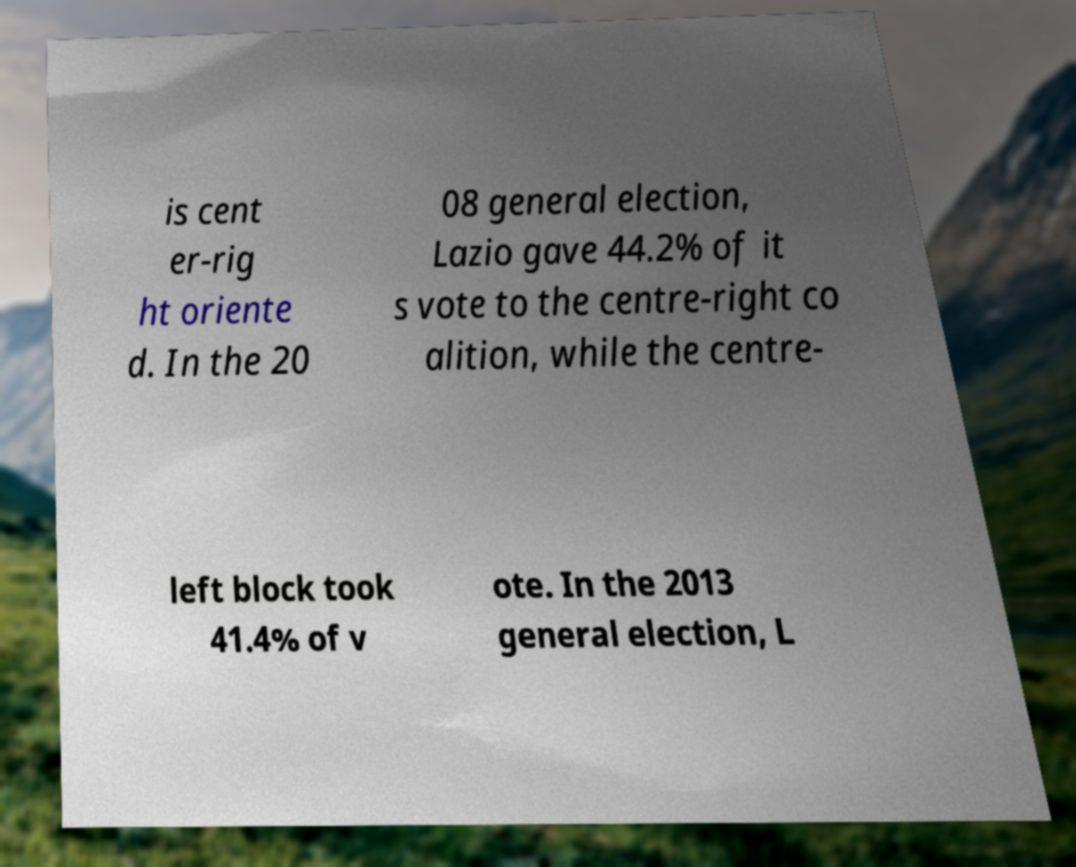Could you assist in decoding the text presented in this image and type it out clearly? is cent er-rig ht oriente d. In the 20 08 general election, Lazio gave 44.2% of it s vote to the centre-right co alition, while the centre- left block took 41.4% of v ote. In the 2013 general election, L 